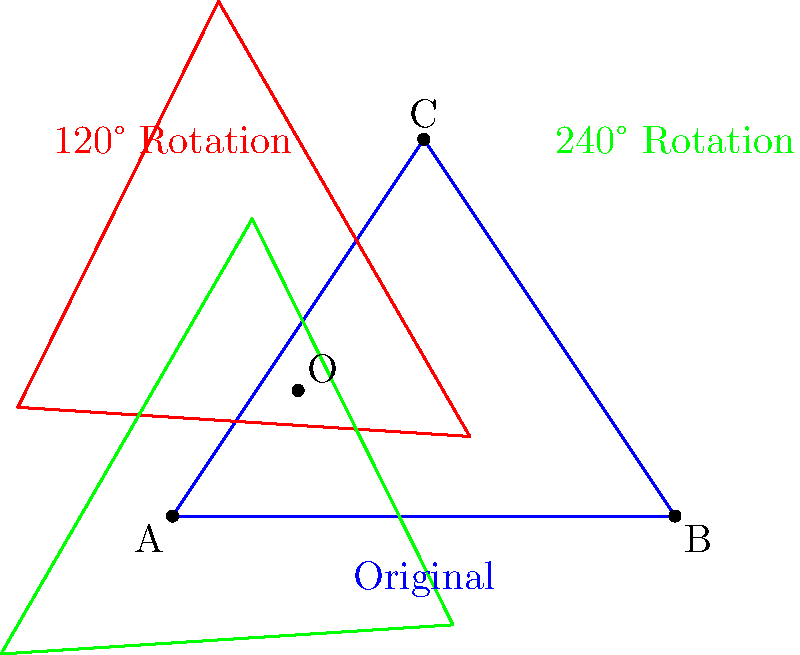A triangle ABC represents the diversity of our community. Point O (1,1) is chosen as the center of rotation to symbolize unity. If we rotate the triangle 120° and then another 120° around point O, which point will coincide with the original position of point C after these rotations? Let's approach this step-by-step:

1) First, we need to understand what a 120° rotation does. It moves each point of the triangle 1/3 of the way around a full circle centered at O.

2) After the first 120° rotation:
   - A moves to where C was
   - B moves to where A was
   - C moves to where B was

3) After the second 120° rotation:
   - The point that was at A (originally B) moves to where C is
   - The point that was at B (originally C) moves to where A is
   - The point that was at C (originally A) moves to where B is

4) Therefore, after two 120° rotations:
   - A ends up where B was originally
   - B ends up where C was originally
   - C ends up where A was originally

5) The question asks which point will coincide with the original position of C. From our analysis, we can see that B ends up in C's original position.
Answer: B 